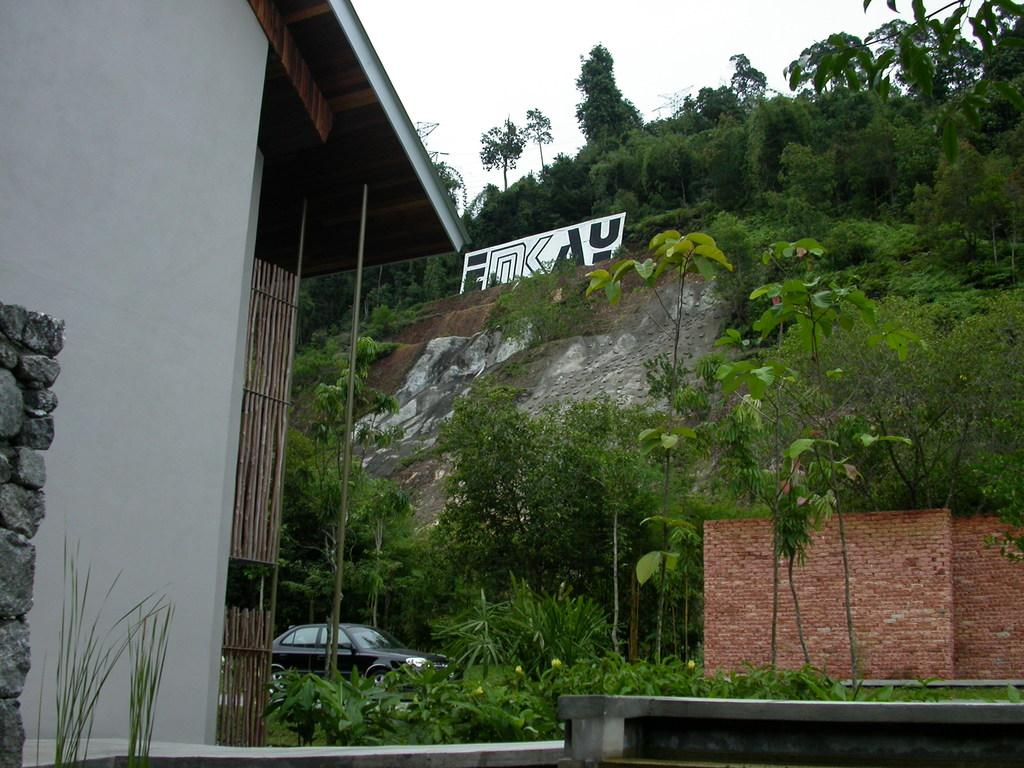What type of structure is visible in the image? There is a house in the image. What is located in front of the house? There is a car in front of the house. What type of natural elements can be seen in the image? There are trees and plants in the image. What is on the mountain in the image? There is a board on the mountain. What type of barrier is present in the image? There is a brick wall in the image. What type of pet can be seen reading a book in the image? There is no pet or book present in the image. What selection of items can be seen in the image? The image contains a house, a car, trees, a board on the mountain, and a brick wall. 